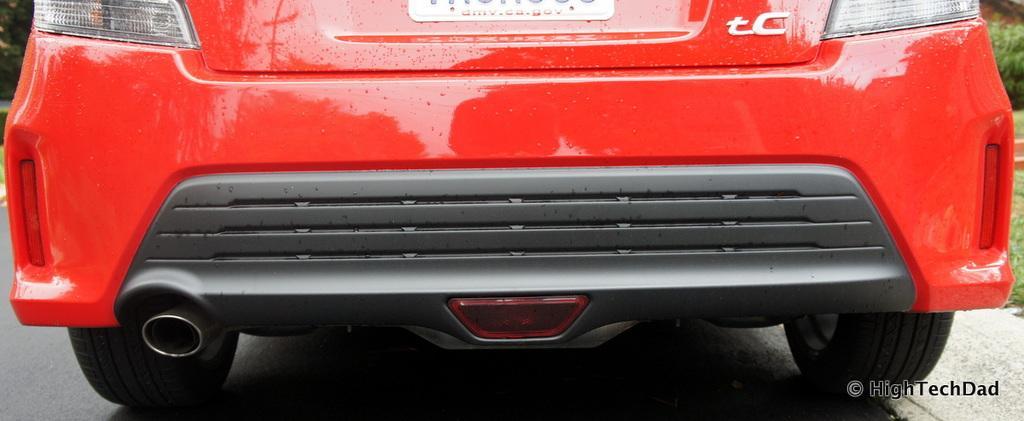Please provide a concise description of this image. In this image we can see a vehicle. On the vehicle we can see some text. In the bottom right we can see some text. On the right side, we can see grass and plants. 